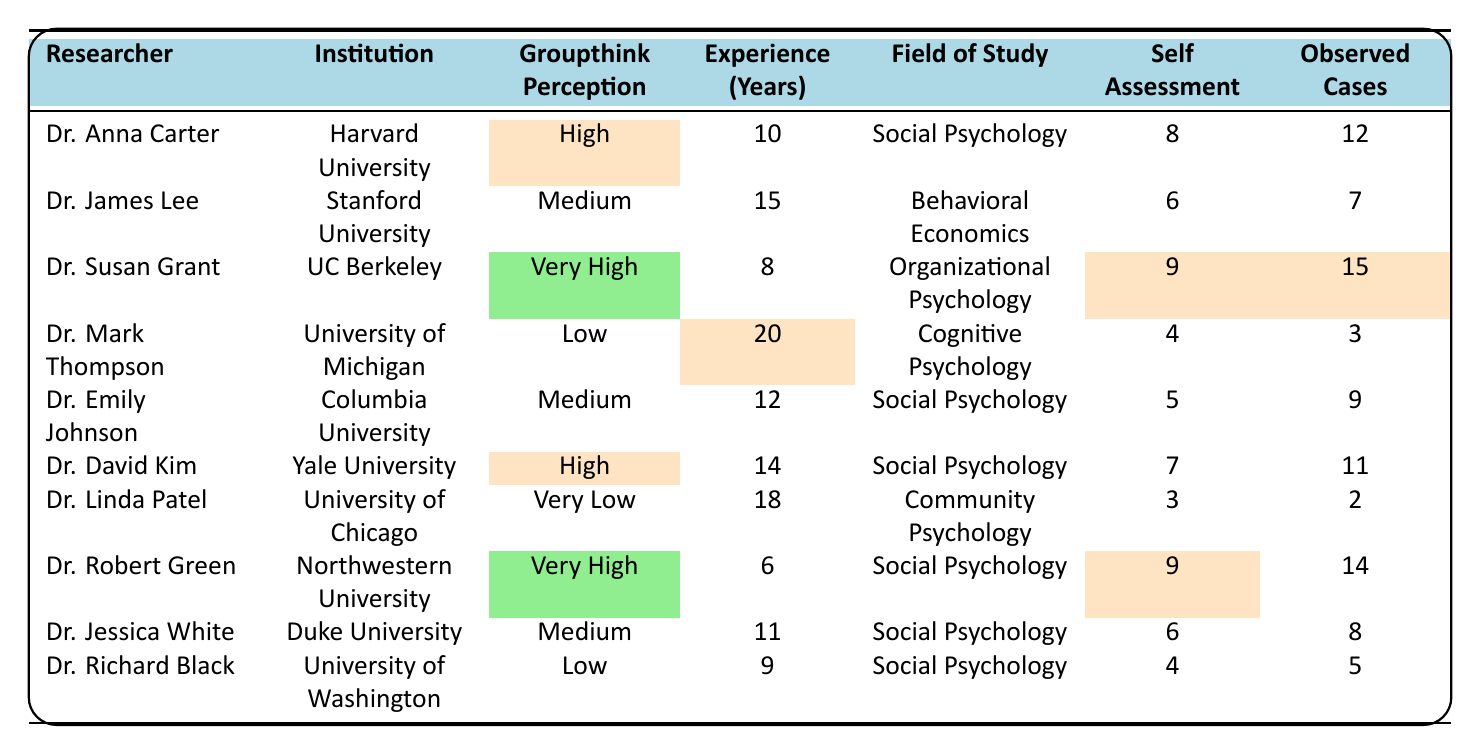What is the perception of groupthink for Dr. Susan Grant? According to the table, Dr. Susan Grant has a perception of groupthink categorized as "Very High."
Answer: Very High How many observed cases of groupthink did Dr. Robert Green report? Dr. Robert Green reported 14 observed cases of groupthink, as indicated in the table.
Answer: 14 What is the average self-assessment score of researchers with a "High" perception of groupthink? The self-assessment scores for researchers with a "High" perception are 8 (Dr. Anna Carter) and 7 (Dr. David Kim). The average is calculated as (8 + 7) / 2 = 7.5.
Answer: 7.5 Is there any researcher who has a perception of groupthink as "Very Low"? Yes, Dr. Linda Patel has a perception of groupthink categorized as "Very Low."
Answer: Yes Which researcher has the least experience in years? Dr. Susan Grant has the least experience with 8 years, compared to others in the table.
Answer: 8 years Count all researchers who perceive groupthink as "Medium." There are 4 researchers with a "Medium" perception: Dr. James Lee, Dr. Emily Johnson, Dr. Jessica White, and Dr. Susan Grant. Therefore, the count is 4.
Answer: 4 How many observed cases are reported by the researcher with the highest self-assessment score? The highest self-assessment score is 9, reported by Dr. Susan Grant and Dr. Robert Green. Dr. Susan Grant has 15 observed cases while Dr. Robert Green has 14. Thus, 15 is the highest observed cases.
Answer: 15 What is the difference in observed groupthink cases between the one with the highest and the lowest perceptions? The highest perceived groupthink cases come from Dr. Susan Grant with 15 cases, while the lowest is Dr. Linda Patel with 2 cases. The difference is calculated as 15 - 2 = 13.
Answer: 13 Which institution does the researcher with the most experience work at, and what is their perception of groupthink? Dr. Mark Thompson has the most experience with 20 years at the University of Michigan, and he perceives groupthink as "Low."
Answer: University of Michigan, Low How does the perception of groupthink correlate with self-assessment scores among these researchers? Analyzing the table, researchers with "Very High" perceptions (Dr. Susan Grant and Dr. Robert Green) have high self-assessment scores (9), whereas those with "Low" perceptions (Dr. Mark Thompson and Dr. Richard Black) have lower self-assessment scores (4). Thus, higher perceptions generally correlate with higher self-assessment scores.
Answer: Higher perceptions correlate with higher self-assessment scores 